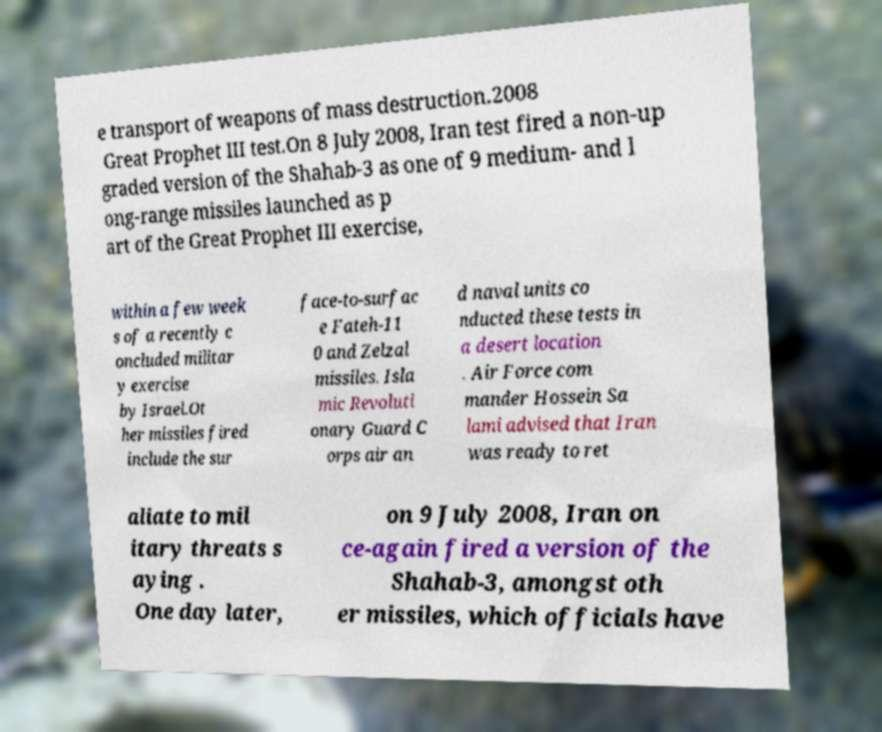What messages or text are displayed in this image? I need them in a readable, typed format. e transport of weapons of mass destruction.2008 Great Prophet III test.On 8 July 2008, Iran test fired a non-up graded version of the Shahab-3 as one of 9 medium- and l ong-range missiles launched as p art of the Great Prophet III exercise, within a few week s of a recently c oncluded militar y exercise by Israel.Ot her missiles fired include the sur face-to-surfac e Fateh-11 0 and Zelzal missiles. Isla mic Revoluti onary Guard C orps air an d naval units co nducted these tests in a desert location . Air Force com mander Hossein Sa lami advised that Iran was ready to ret aliate to mil itary threats s aying . One day later, on 9 July 2008, Iran on ce-again fired a version of the Shahab-3, amongst oth er missiles, which officials have 